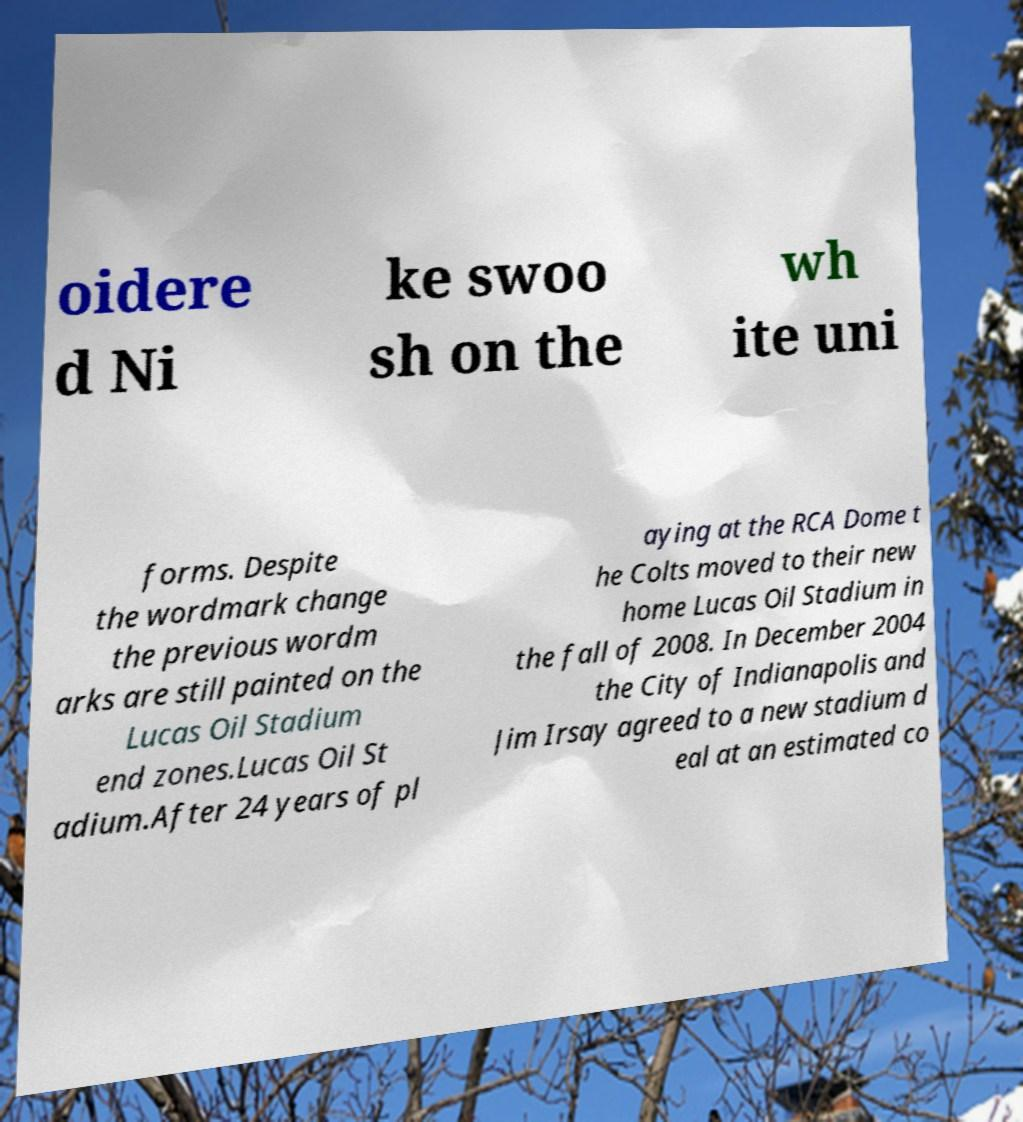Can you read and provide the text displayed in the image?This photo seems to have some interesting text. Can you extract and type it out for me? oidere d Ni ke swoo sh on the wh ite uni forms. Despite the wordmark change the previous wordm arks are still painted on the Lucas Oil Stadium end zones.Lucas Oil St adium.After 24 years of pl aying at the RCA Dome t he Colts moved to their new home Lucas Oil Stadium in the fall of 2008. In December 2004 the City of Indianapolis and Jim Irsay agreed to a new stadium d eal at an estimated co 